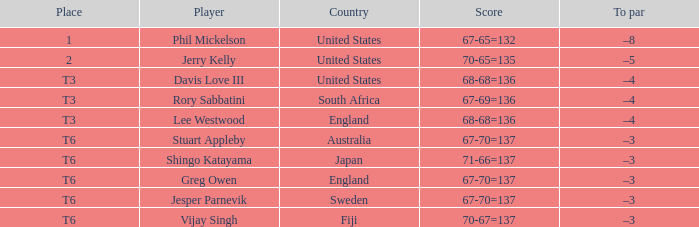I'm looking to parse the entire table for insights. Could you assist me with that? {'header': ['Place', 'Player', 'Country', 'Score', 'To par'], 'rows': [['1', 'Phil Mickelson', 'United States', '67-65=132', '–8'], ['2', 'Jerry Kelly', 'United States', '70-65=135', '–5'], ['T3', 'Davis Love III', 'United States', '68-68=136', '–4'], ['T3', 'Rory Sabbatini', 'South Africa', '67-69=136', '–4'], ['T3', 'Lee Westwood', 'England', '68-68=136', '–4'], ['T6', 'Stuart Appleby', 'Australia', '67-70=137', '–3'], ['T6', 'Shingo Katayama', 'Japan', '71-66=137', '–3'], ['T6', 'Greg Owen', 'England', '67-70=137', '–3'], ['T6', 'Jesper Parnevik', 'Sweden', '67-70=137', '–3'], ['T6', 'Vijay Singh', 'Fiji', '70-67=137', '–3']]} What is the tally for fiji? 70-67=137. 